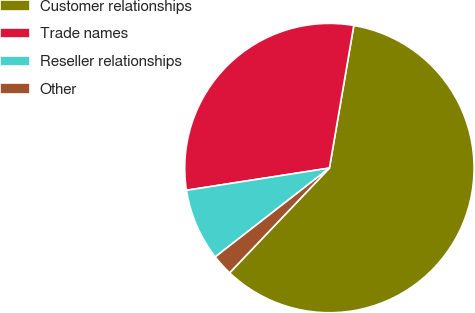<chart> <loc_0><loc_0><loc_500><loc_500><pie_chart><fcel>Customer relationships<fcel>Trade names<fcel>Reseller relationships<fcel>Other<nl><fcel>59.41%<fcel>30.15%<fcel>8.07%<fcel>2.36%<nl></chart> 